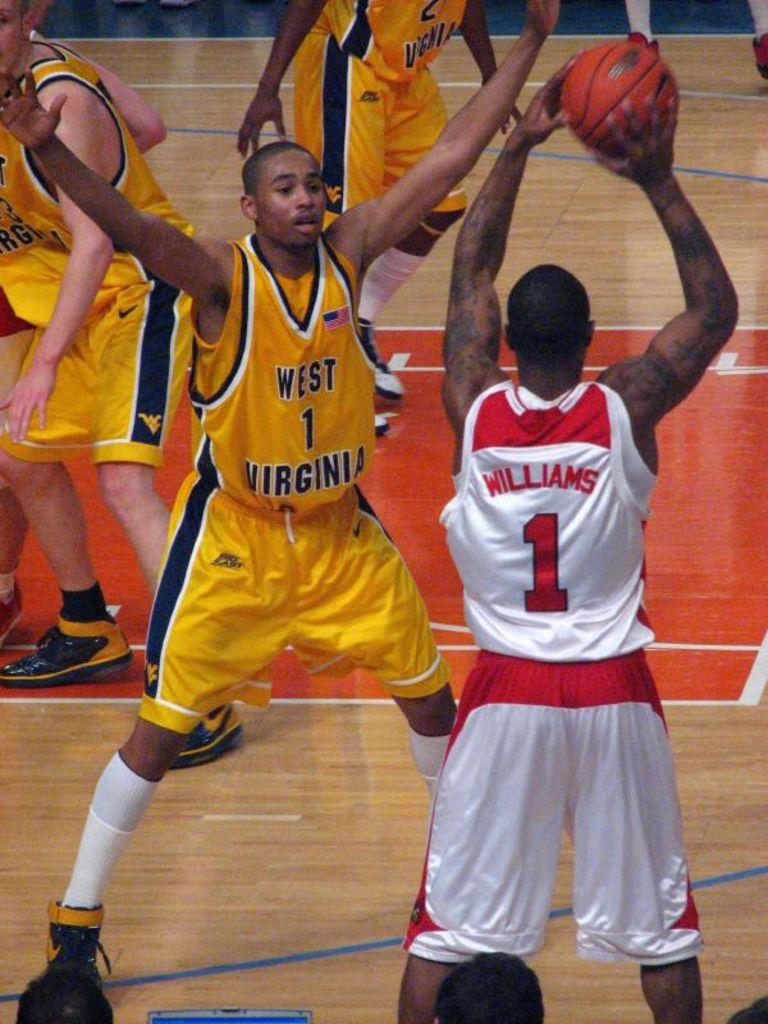<image>
Relay a brief, clear account of the picture shown. The basketball player from West Virginia is trying to block a shot from Williams. 